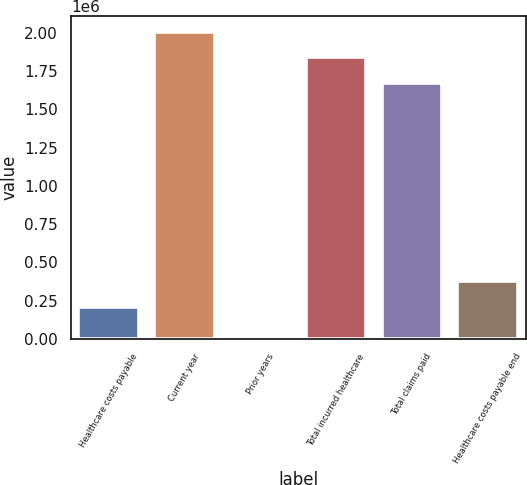<chart> <loc_0><loc_0><loc_500><loc_500><bar_chart><fcel>Healthcare costs payable<fcel>Current year<fcel>Prior years<fcel>Total incurred healthcare<fcel>Total claims paid<fcel>Healthcare costs payable end<nl><fcel>212641<fcel>2.00669e+06<fcel>141<fcel>1.83933e+06<fcel>1.67197e+06<fcel>380001<nl></chart> 